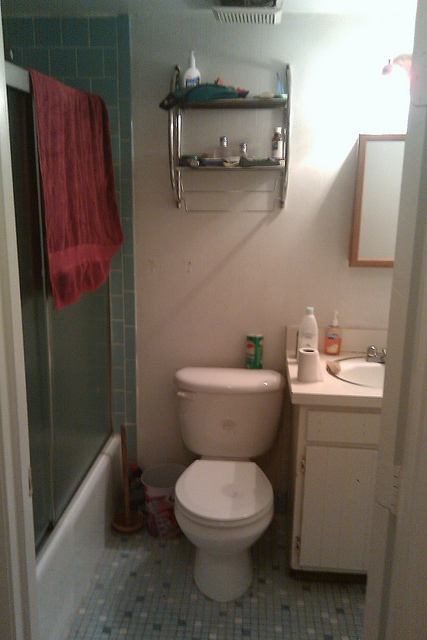Imagine this bathroom being transformed into a luxurious spa. How would it look? Envision this bathroom transformed into a luxurious spa. The tiles on the walls and floor would be replaced with sleek, dark marble or a calming, neutral stone. The shelves above the toilet would be upgraded to elegant, built-in niches holding aromatic candles, essential oils, and plush towels neatly rolled. The shower would feature a rainfall showerhead, a glass door, and a bench with additional spa products. Soft, ambient lighting would replace the current fixtures, creating a serene and relaxing atmosphere. A small indoor plant or bonsai tree could add a touch of nature, completing the transformation into a peaceful spa retreat. 